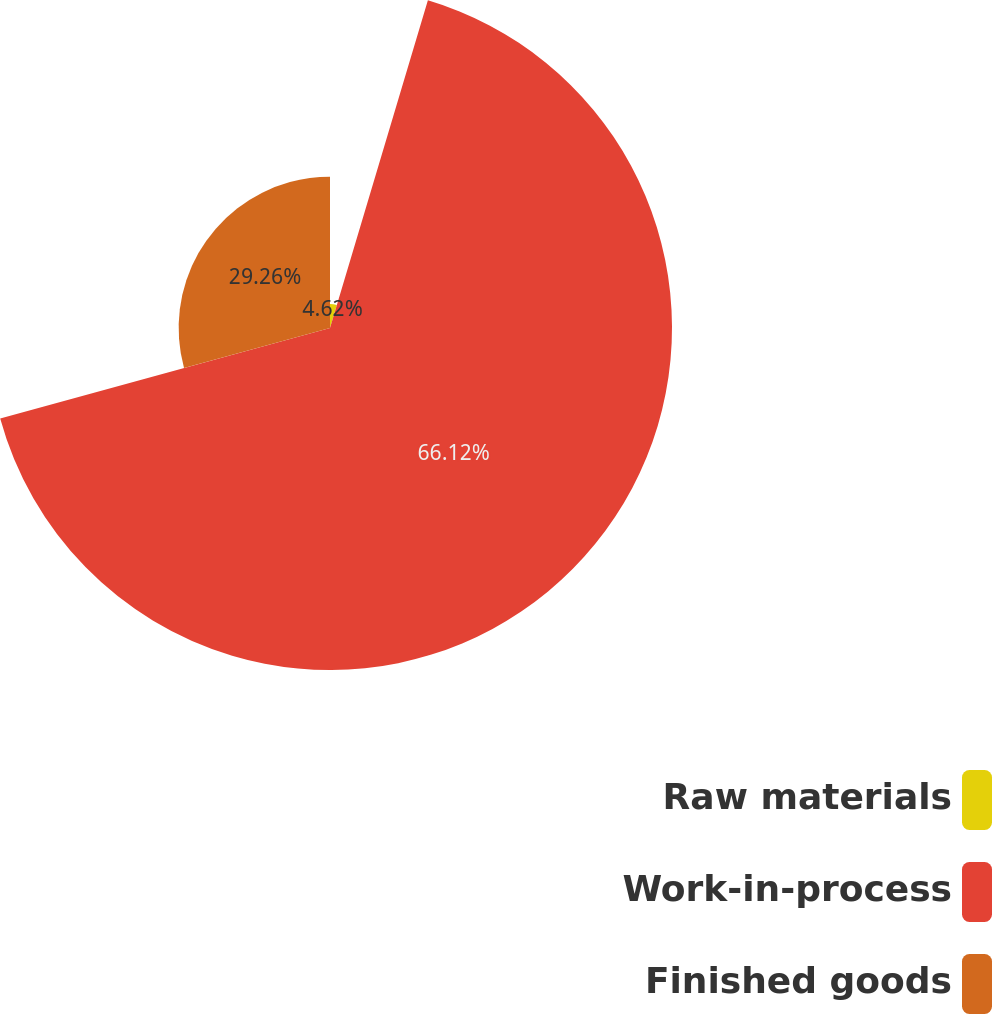<chart> <loc_0><loc_0><loc_500><loc_500><pie_chart><fcel>Raw materials<fcel>Work-in-process<fcel>Finished goods<nl><fcel>4.62%<fcel>66.11%<fcel>29.26%<nl></chart> 